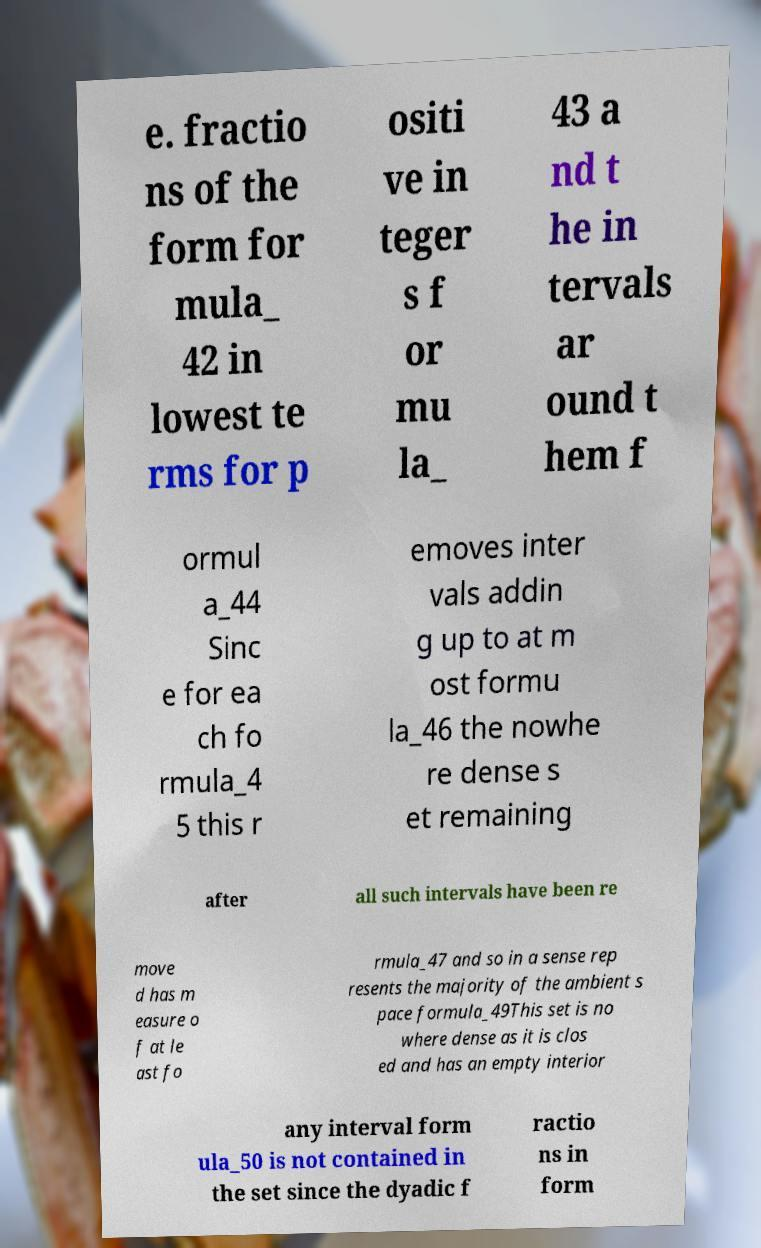Can you accurately transcribe the text from the provided image for me? e. fractio ns of the form for mula_ 42 in lowest te rms for p ositi ve in teger s f or mu la_ 43 a nd t he in tervals ar ound t hem f ormul a_44 Sinc e for ea ch fo rmula_4 5 this r emoves inter vals addin g up to at m ost formu la_46 the nowhe re dense s et remaining after all such intervals have been re move d has m easure o f at le ast fo rmula_47 and so in a sense rep resents the majority of the ambient s pace formula_49This set is no where dense as it is clos ed and has an empty interior any interval form ula_50 is not contained in the set since the dyadic f ractio ns in form 